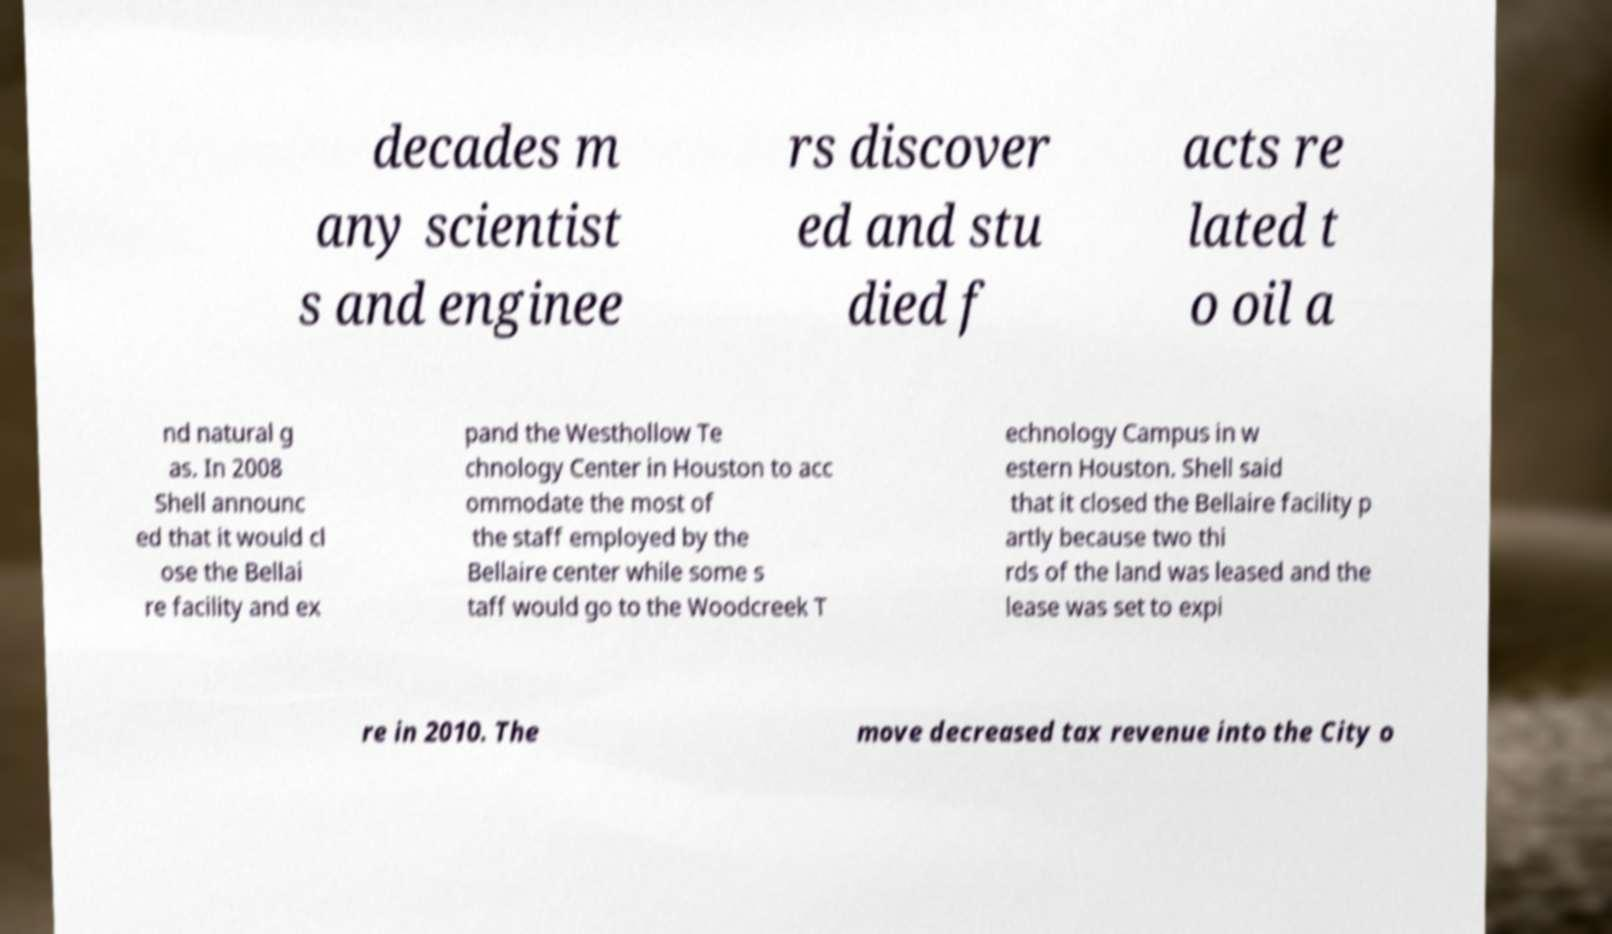Please read and relay the text visible in this image. What does it say? decades m any scientist s and enginee rs discover ed and stu died f acts re lated t o oil a nd natural g as. In 2008 Shell announc ed that it would cl ose the Bellai re facility and ex pand the Westhollow Te chnology Center in Houston to acc ommodate the most of the staff employed by the Bellaire center while some s taff would go to the Woodcreek T echnology Campus in w estern Houston. Shell said that it closed the Bellaire facility p artly because two thi rds of the land was leased and the lease was set to expi re in 2010. The move decreased tax revenue into the City o 